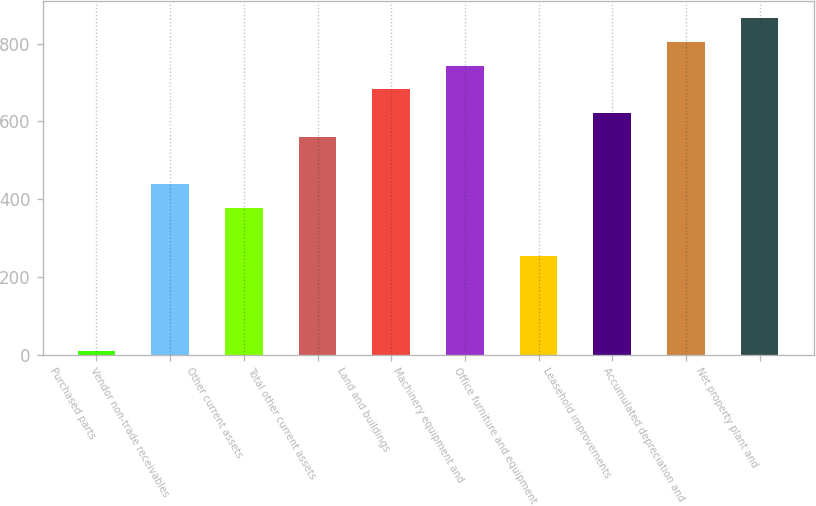Convert chart to OTSL. <chart><loc_0><loc_0><loc_500><loc_500><bar_chart><fcel>Purchased parts<fcel>Vendor non-trade receivables<fcel>Other current assets<fcel>Total other current assets<fcel>Land and buildings<fcel>Machinery equipment and<fcel>Office furniture and equipment<fcel>Leasehold improvements<fcel>Accumulated depreciation and<fcel>Net property plant and<nl><fcel>9<fcel>437.4<fcel>376.2<fcel>559.8<fcel>682.2<fcel>743.4<fcel>253.8<fcel>621<fcel>804.6<fcel>865.8<nl></chart> 